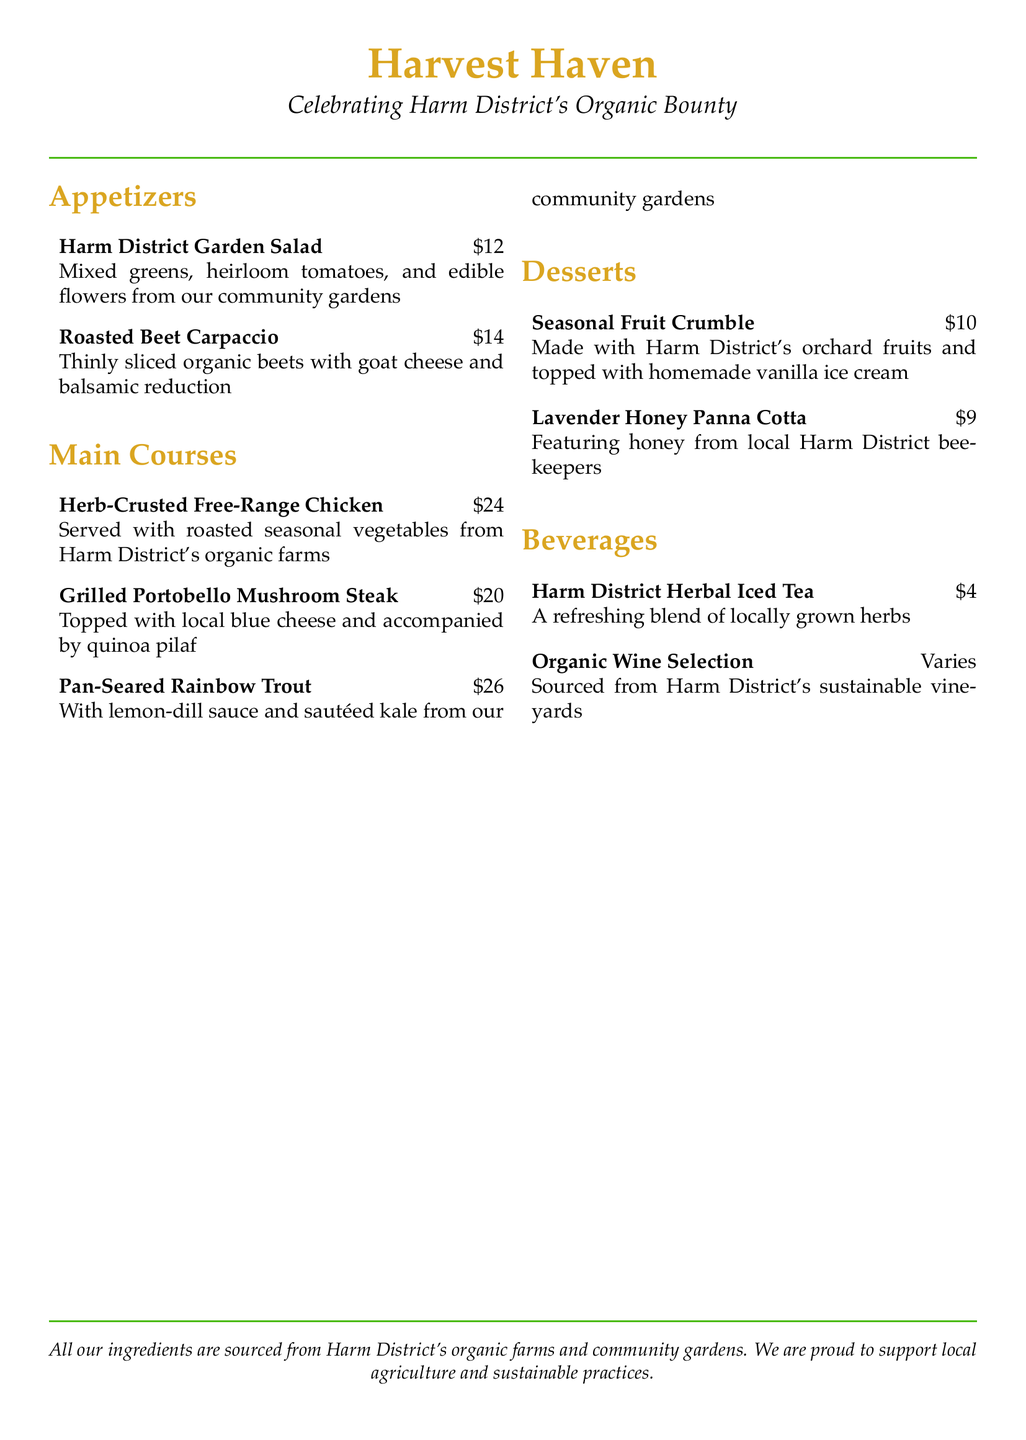What is the price of the Harm District Garden Salad? The price of the Harm District Garden Salad is listed in the document as $12.
Answer: $12 What is the main ingredient in the Roasted Beet Carpaccio? The main ingredient in the Roasted Beet Carpaccio is organic beets, as mentioned in the description.
Answer: organic beets How much does the Grilled Portobello Mushroom Steak cost? The cost of the Grilled Portobello Mushroom Steak is indicated as $20 in the menu.
Answer: $20 Which dessert features honey from local beekeepers? The dessert that features honey from local beekeepers is the Lavender Honey Panna Cotta, as stated in the menu.
Answer: Lavender Honey Panna Cotta What type of wine is offered on the menu? The menu mentions an Organic Wine Selection that is sourced from Harm District's sustainable vineyards.
Answer: Organic Wine Selection How many appetizers are listed in the menu? The total number of appetizers is counted from the menu and there are two listed: Harm District Garden Salad and Roasted Beet Carpaccio.
Answer: two What is the primary focus of the menu? The primary focus of the menu is to celebrate Harm District's organic bounty, highlighted in the title.
Answer: Harm District's organic bounty Which main course includes quinoa pilaf? The main course that includes quinoa pilaf is the Grilled Portobello Mushroom Steak, as stated in the menu.
Answer: Grilled Portobello Mushroom Steak 